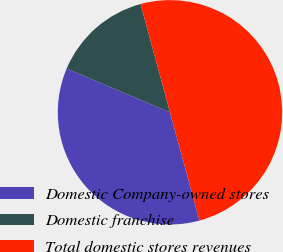<chart> <loc_0><loc_0><loc_500><loc_500><pie_chart><fcel>Domestic Company-owned stores<fcel>Domestic franchise<fcel>Total domestic stores revenues<nl><fcel>35.6%<fcel>14.4%<fcel>50.0%<nl></chart> 